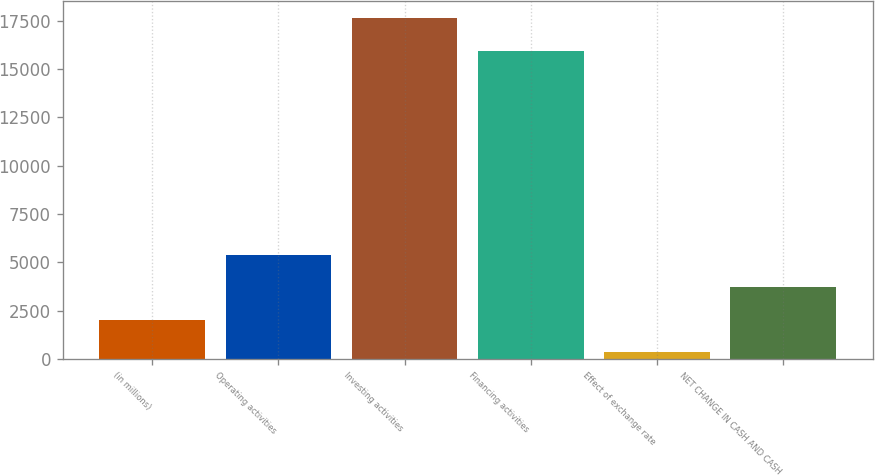Convert chart to OTSL. <chart><loc_0><loc_0><loc_500><loc_500><bar_chart><fcel>(in millions)<fcel>Operating activities<fcel>Investing activities<fcel>Financing activities<fcel>Effect of exchange rate<fcel>NET CHANGE IN CASH AND CASH<nl><fcel>2023.5<fcel>5364.5<fcel>17619.5<fcel>15949<fcel>353<fcel>3694<nl></chart> 